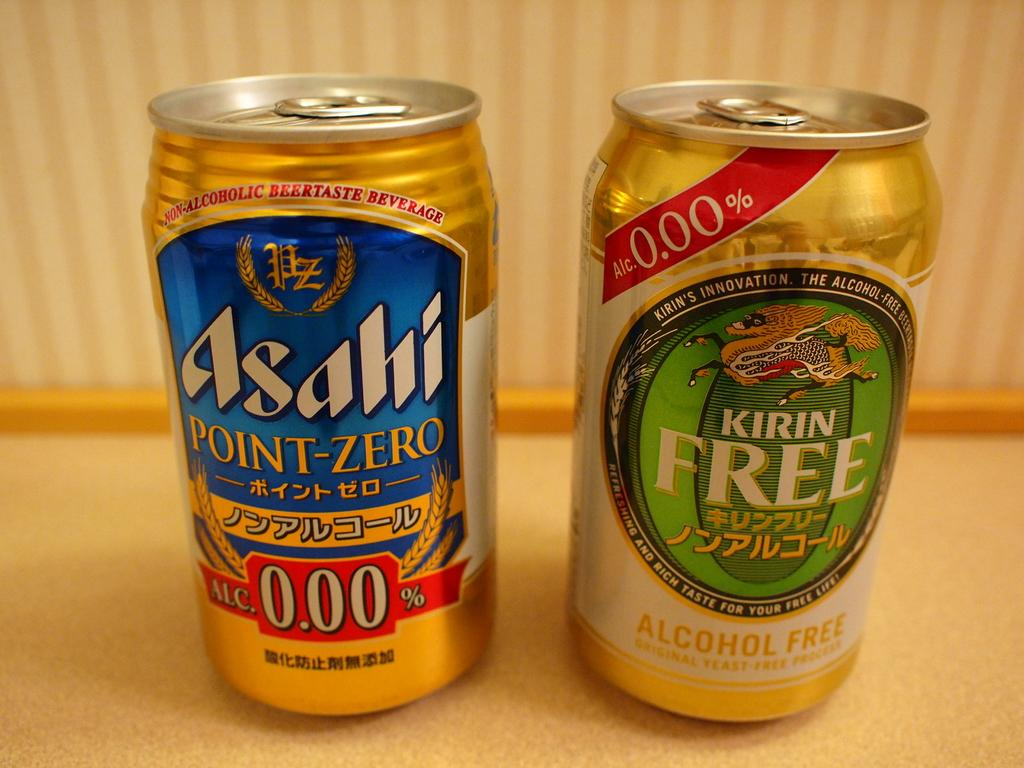<image>
Relay a brief, clear account of the picture shown. two gold aluminum cans of alcohol free beer 